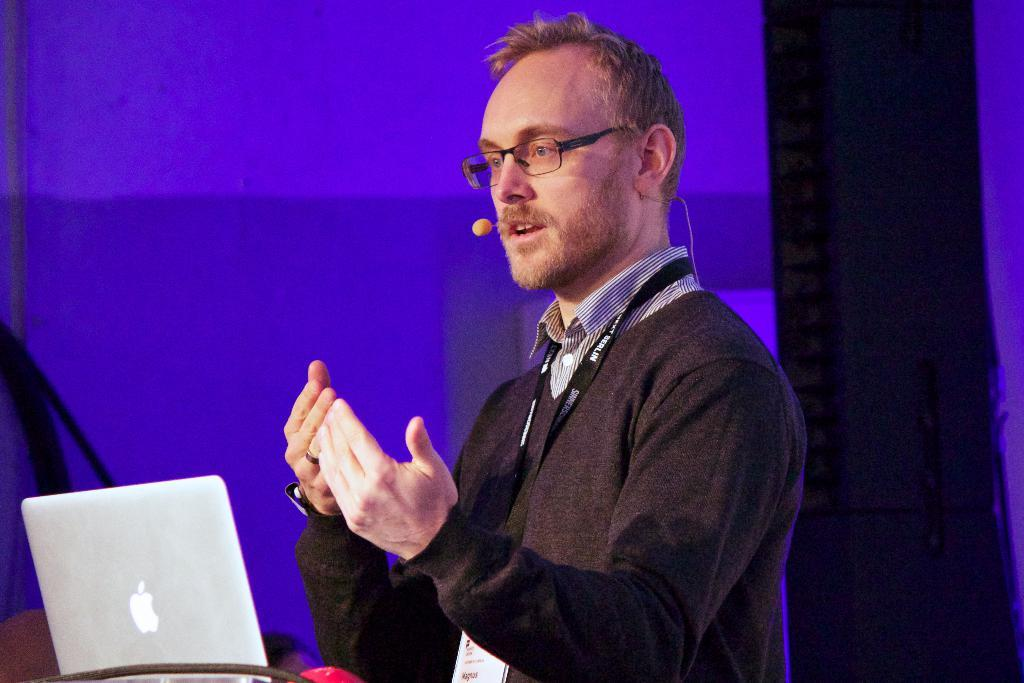Who is present in the image? There is a man in the image. What object is the man holding in the image? The man is holding a microphone in the image. What electronic device is visible in the image? There is a laptop in the image. Can you describe the background of the image? There are objects in the background of the image. What type of lead is the man using to communicate with the beetle in the image? There is no beetle present in the image, and the man is not using any lead to communicate. 